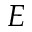<formula> <loc_0><loc_0><loc_500><loc_500>E</formula> 